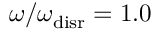Convert formula to latex. <formula><loc_0><loc_0><loc_500><loc_500>{ \omega / \omega _ { d i s r } = 1 . 0 }</formula> 